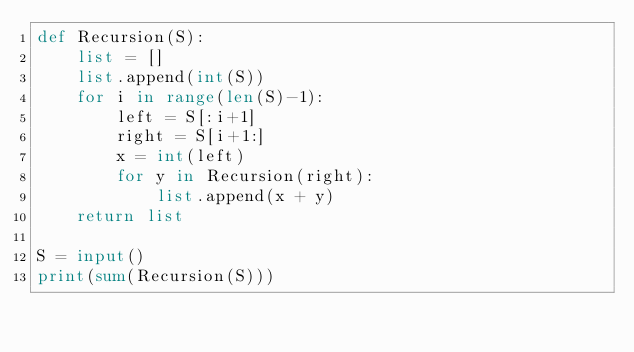<code> <loc_0><loc_0><loc_500><loc_500><_Python_>def Recursion(S):
    list = []
    list.append(int(S))
    for i in range(len(S)-1):
        left = S[:i+1]
        right = S[i+1:]
        x = int(left)
        for y in Recursion(right):
            list.append(x + y)
    return list

S = input()
print(sum(Recursion(S)))
</code> 